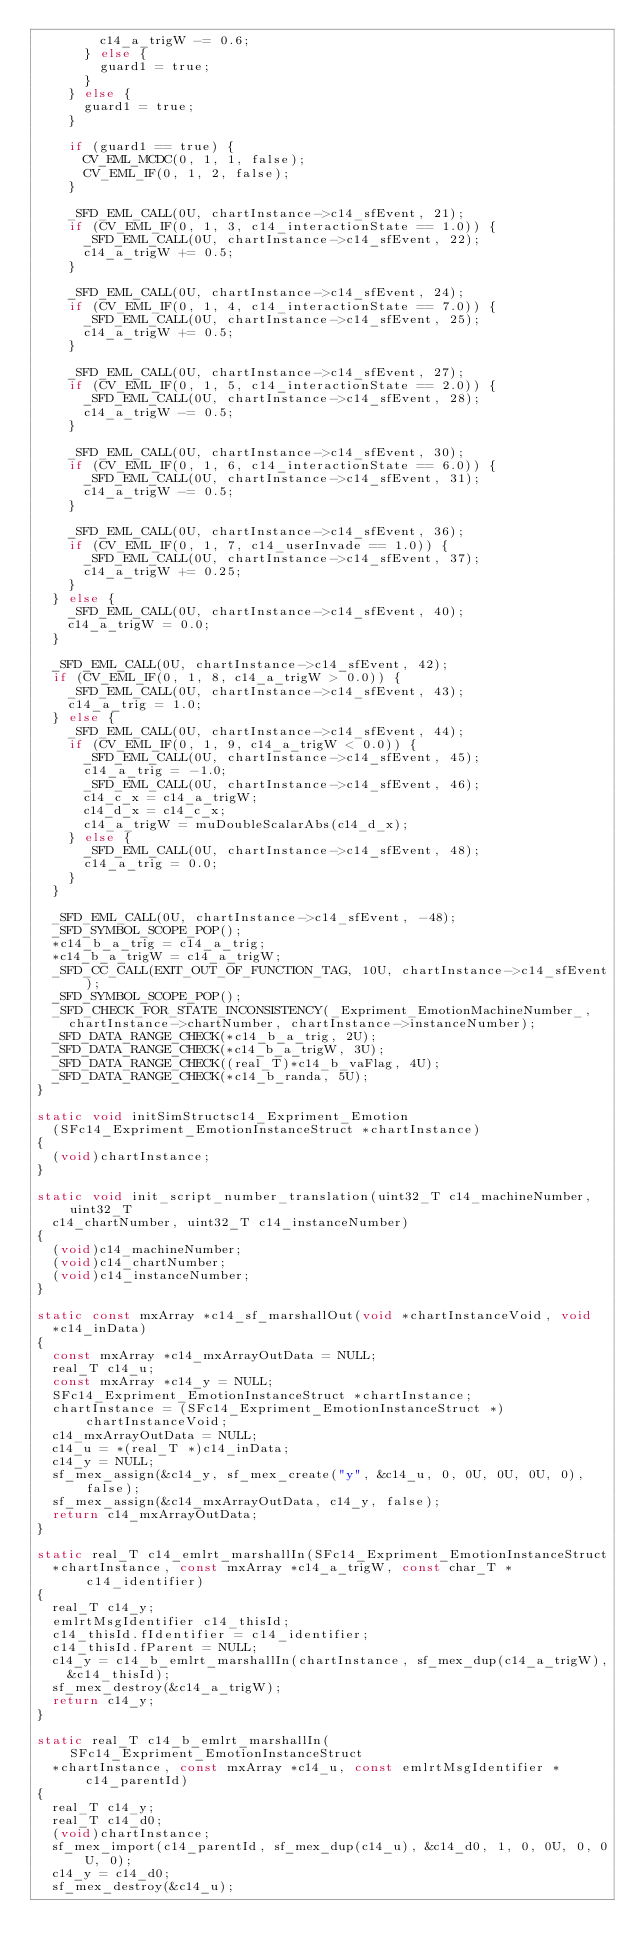Convert code to text. <code><loc_0><loc_0><loc_500><loc_500><_C_>        c14_a_trigW -= 0.6;
      } else {
        guard1 = true;
      }
    } else {
      guard1 = true;
    }

    if (guard1 == true) {
      CV_EML_MCDC(0, 1, 1, false);
      CV_EML_IF(0, 1, 2, false);
    }

    _SFD_EML_CALL(0U, chartInstance->c14_sfEvent, 21);
    if (CV_EML_IF(0, 1, 3, c14_interactionState == 1.0)) {
      _SFD_EML_CALL(0U, chartInstance->c14_sfEvent, 22);
      c14_a_trigW += 0.5;
    }

    _SFD_EML_CALL(0U, chartInstance->c14_sfEvent, 24);
    if (CV_EML_IF(0, 1, 4, c14_interactionState == 7.0)) {
      _SFD_EML_CALL(0U, chartInstance->c14_sfEvent, 25);
      c14_a_trigW += 0.5;
    }

    _SFD_EML_CALL(0U, chartInstance->c14_sfEvent, 27);
    if (CV_EML_IF(0, 1, 5, c14_interactionState == 2.0)) {
      _SFD_EML_CALL(0U, chartInstance->c14_sfEvent, 28);
      c14_a_trigW -= 0.5;
    }

    _SFD_EML_CALL(0U, chartInstance->c14_sfEvent, 30);
    if (CV_EML_IF(0, 1, 6, c14_interactionState == 6.0)) {
      _SFD_EML_CALL(0U, chartInstance->c14_sfEvent, 31);
      c14_a_trigW -= 0.5;
    }

    _SFD_EML_CALL(0U, chartInstance->c14_sfEvent, 36);
    if (CV_EML_IF(0, 1, 7, c14_userInvade == 1.0)) {
      _SFD_EML_CALL(0U, chartInstance->c14_sfEvent, 37);
      c14_a_trigW += 0.25;
    }
  } else {
    _SFD_EML_CALL(0U, chartInstance->c14_sfEvent, 40);
    c14_a_trigW = 0.0;
  }

  _SFD_EML_CALL(0U, chartInstance->c14_sfEvent, 42);
  if (CV_EML_IF(0, 1, 8, c14_a_trigW > 0.0)) {
    _SFD_EML_CALL(0U, chartInstance->c14_sfEvent, 43);
    c14_a_trig = 1.0;
  } else {
    _SFD_EML_CALL(0U, chartInstance->c14_sfEvent, 44);
    if (CV_EML_IF(0, 1, 9, c14_a_trigW < 0.0)) {
      _SFD_EML_CALL(0U, chartInstance->c14_sfEvent, 45);
      c14_a_trig = -1.0;
      _SFD_EML_CALL(0U, chartInstance->c14_sfEvent, 46);
      c14_c_x = c14_a_trigW;
      c14_d_x = c14_c_x;
      c14_a_trigW = muDoubleScalarAbs(c14_d_x);
    } else {
      _SFD_EML_CALL(0U, chartInstance->c14_sfEvent, 48);
      c14_a_trig = 0.0;
    }
  }

  _SFD_EML_CALL(0U, chartInstance->c14_sfEvent, -48);
  _SFD_SYMBOL_SCOPE_POP();
  *c14_b_a_trig = c14_a_trig;
  *c14_b_a_trigW = c14_a_trigW;
  _SFD_CC_CALL(EXIT_OUT_OF_FUNCTION_TAG, 10U, chartInstance->c14_sfEvent);
  _SFD_SYMBOL_SCOPE_POP();
  _SFD_CHECK_FOR_STATE_INCONSISTENCY(_Expriment_EmotionMachineNumber_,
    chartInstance->chartNumber, chartInstance->instanceNumber);
  _SFD_DATA_RANGE_CHECK(*c14_b_a_trig, 2U);
  _SFD_DATA_RANGE_CHECK(*c14_b_a_trigW, 3U);
  _SFD_DATA_RANGE_CHECK((real_T)*c14_b_vaFlag, 4U);
  _SFD_DATA_RANGE_CHECK(*c14_b_randa, 5U);
}

static void initSimStructsc14_Expriment_Emotion
  (SFc14_Expriment_EmotionInstanceStruct *chartInstance)
{
  (void)chartInstance;
}

static void init_script_number_translation(uint32_T c14_machineNumber, uint32_T
  c14_chartNumber, uint32_T c14_instanceNumber)
{
  (void)c14_machineNumber;
  (void)c14_chartNumber;
  (void)c14_instanceNumber;
}

static const mxArray *c14_sf_marshallOut(void *chartInstanceVoid, void
  *c14_inData)
{
  const mxArray *c14_mxArrayOutData = NULL;
  real_T c14_u;
  const mxArray *c14_y = NULL;
  SFc14_Expriment_EmotionInstanceStruct *chartInstance;
  chartInstance = (SFc14_Expriment_EmotionInstanceStruct *)chartInstanceVoid;
  c14_mxArrayOutData = NULL;
  c14_u = *(real_T *)c14_inData;
  c14_y = NULL;
  sf_mex_assign(&c14_y, sf_mex_create("y", &c14_u, 0, 0U, 0U, 0U, 0), false);
  sf_mex_assign(&c14_mxArrayOutData, c14_y, false);
  return c14_mxArrayOutData;
}

static real_T c14_emlrt_marshallIn(SFc14_Expriment_EmotionInstanceStruct
  *chartInstance, const mxArray *c14_a_trigW, const char_T *c14_identifier)
{
  real_T c14_y;
  emlrtMsgIdentifier c14_thisId;
  c14_thisId.fIdentifier = c14_identifier;
  c14_thisId.fParent = NULL;
  c14_y = c14_b_emlrt_marshallIn(chartInstance, sf_mex_dup(c14_a_trigW),
    &c14_thisId);
  sf_mex_destroy(&c14_a_trigW);
  return c14_y;
}

static real_T c14_b_emlrt_marshallIn(SFc14_Expriment_EmotionInstanceStruct
  *chartInstance, const mxArray *c14_u, const emlrtMsgIdentifier *c14_parentId)
{
  real_T c14_y;
  real_T c14_d0;
  (void)chartInstance;
  sf_mex_import(c14_parentId, sf_mex_dup(c14_u), &c14_d0, 1, 0, 0U, 0, 0U, 0);
  c14_y = c14_d0;
  sf_mex_destroy(&c14_u);</code> 